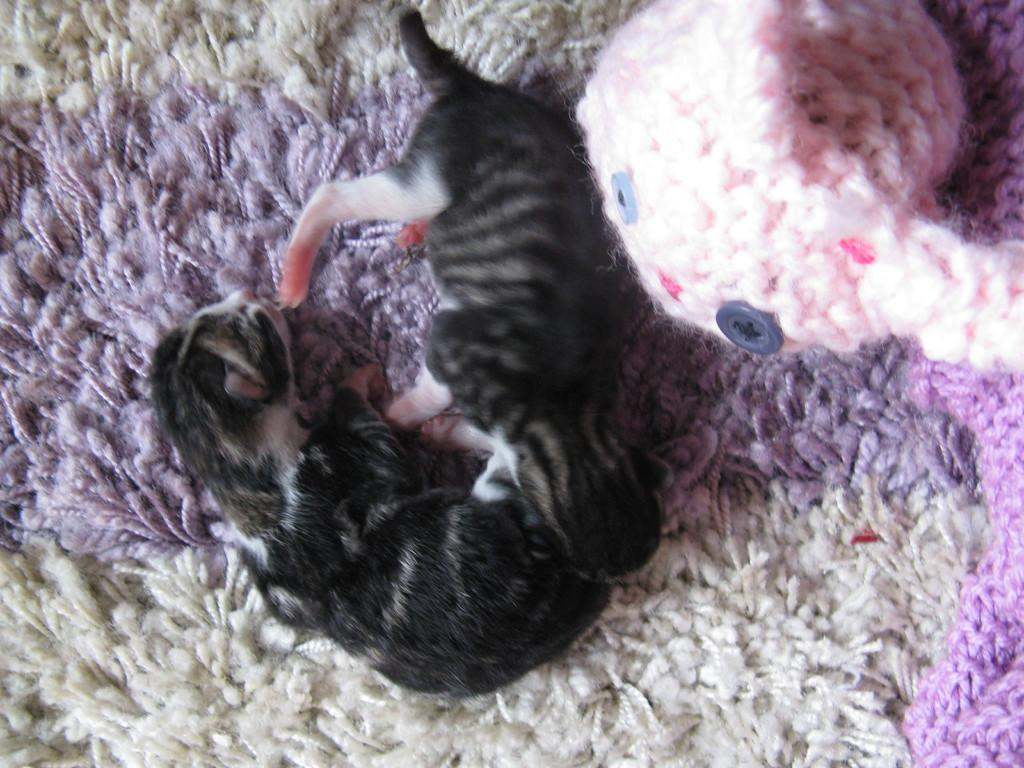What type of animals are present in the image? There are two newborn animals in the image. What is the color of the animals? The animals are black in color. How many icicles are hanging from the animals in the image? There are no icicles present in the image; the animals are black and not associated with icicles. 